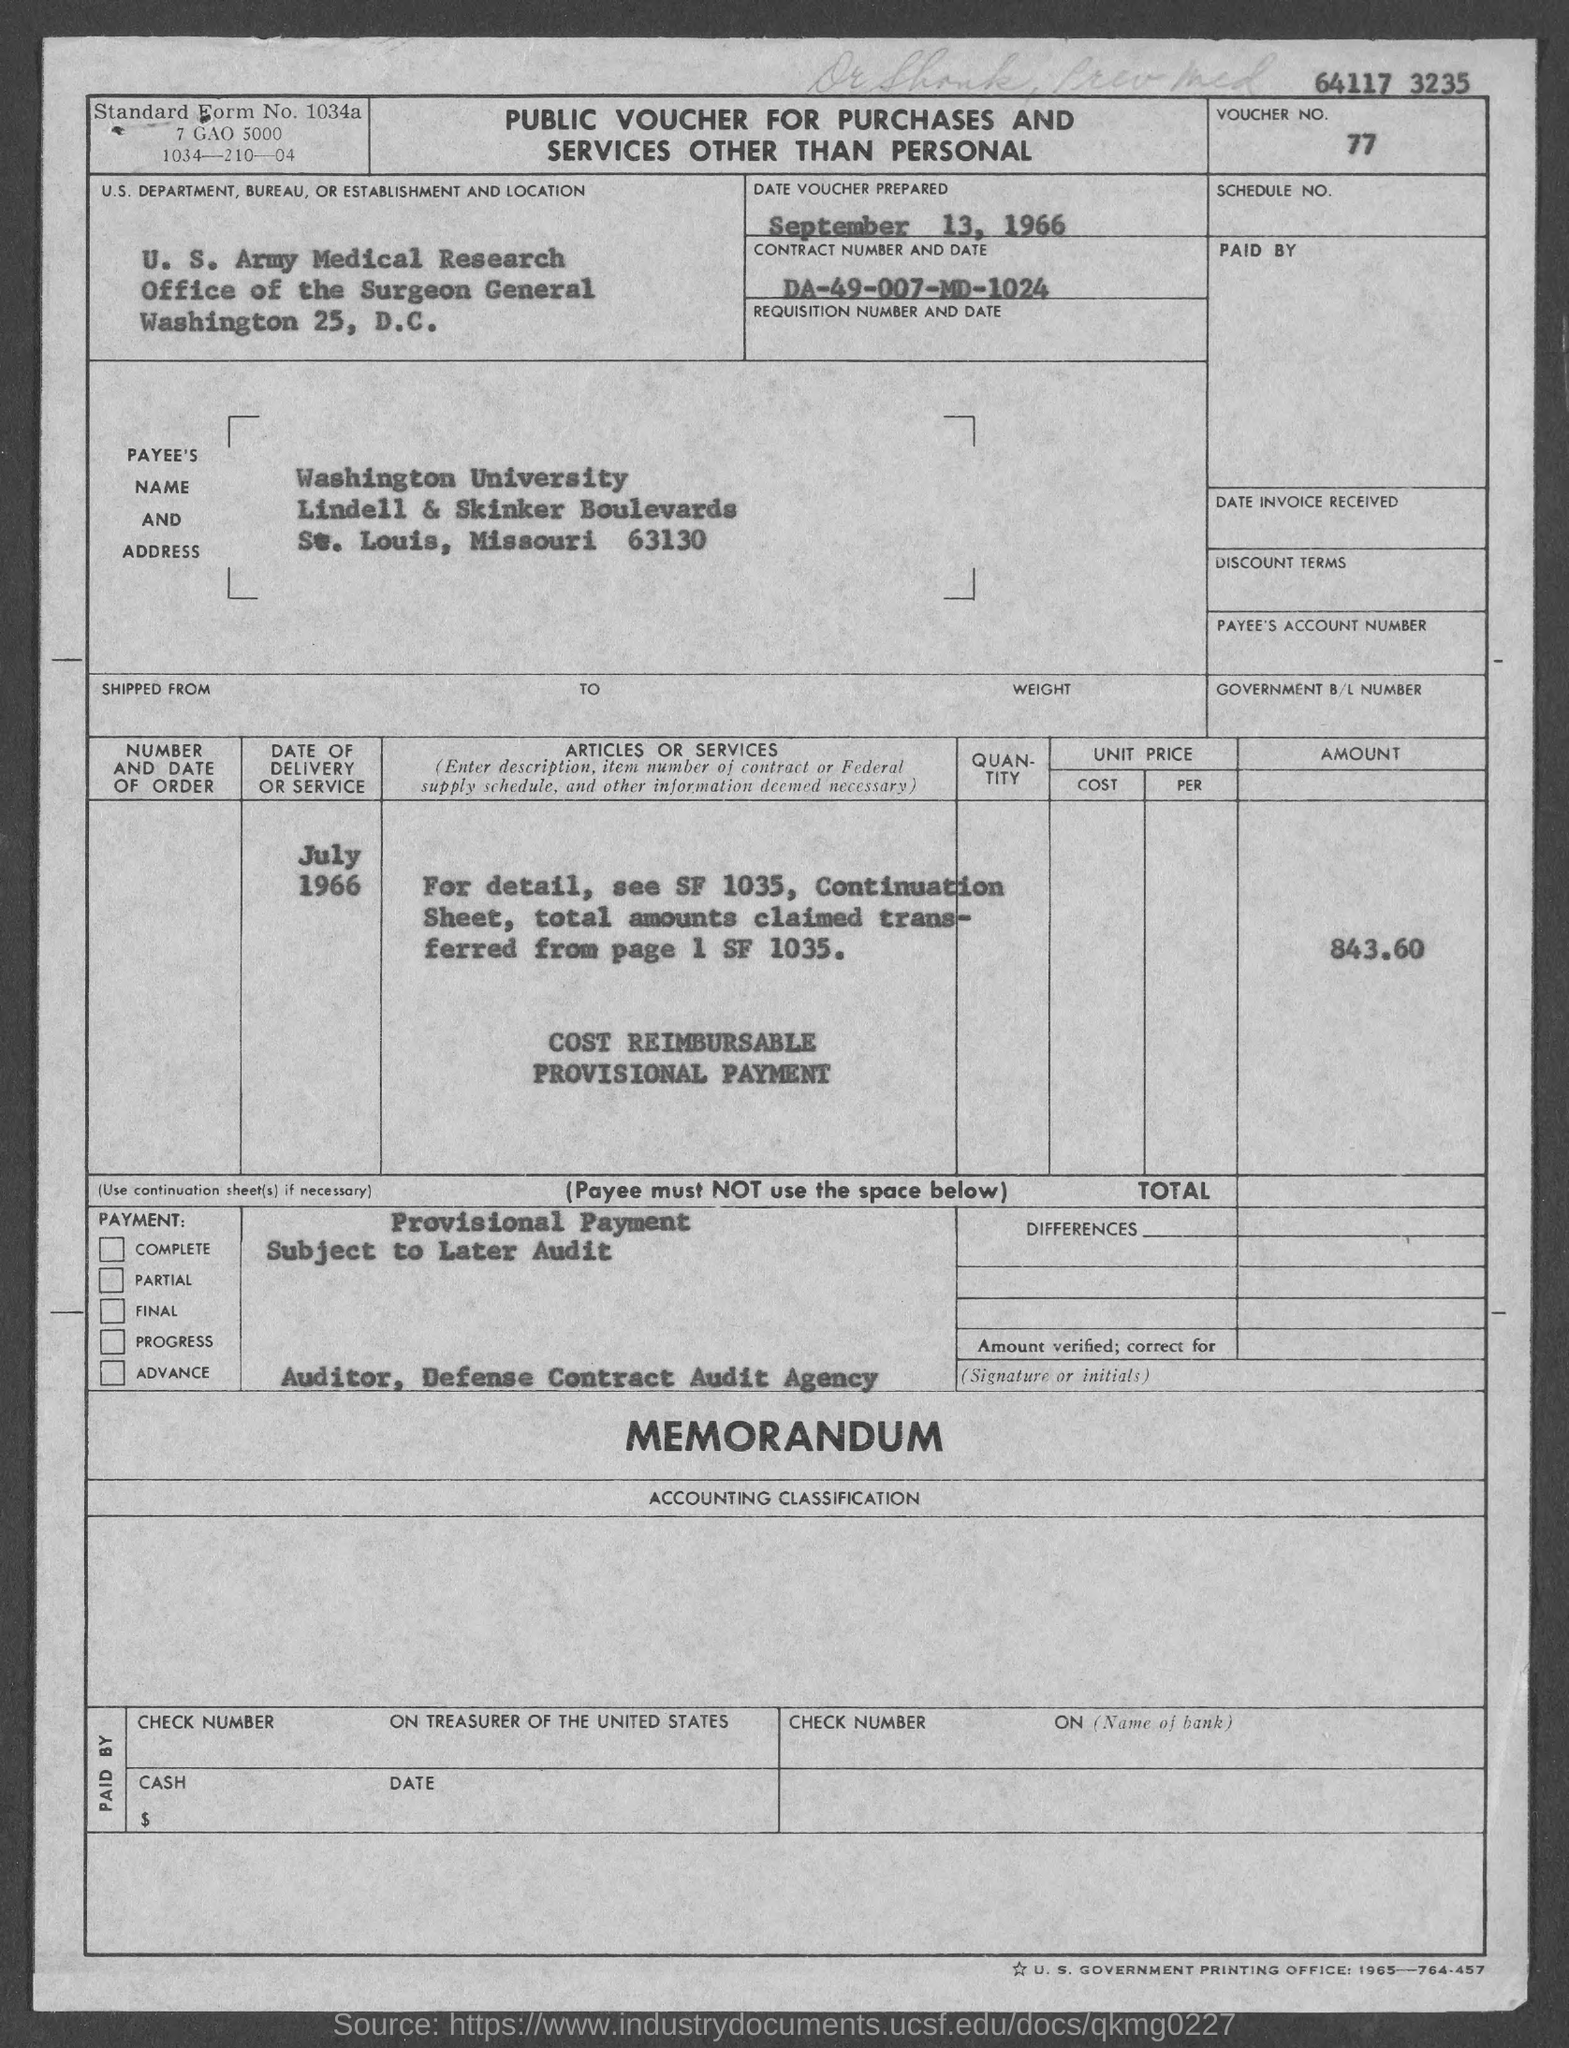Highlight a few significant elements in this photo. The voucher number is 77... What is the standard form number?" is a question. The standard form number is 1034a. On September 13, 1966, the voucher was prepared. The contract number is 007-MD-1024. 